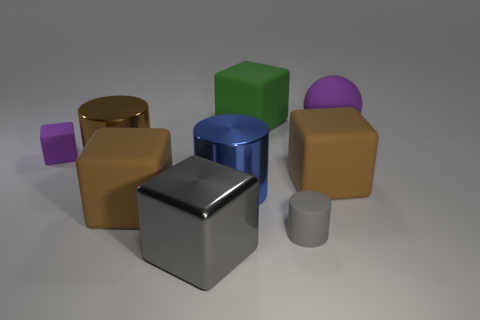Subtract all yellow cubes. Subtract all cyan balls. How many cubes are left? 5 Subtract all spheres. How many objects are left? 8 Subtract 0 red cubes. How many objects are left? 9 Subtract all small purple matte cubes. Subtract all big brown matte objects. How many objects are left? 6 Add 5 big gray shiny cubes. How many big gray shiny cubes are left? 6 Add 9 red cylinders. How many red cylinders exist? 9 